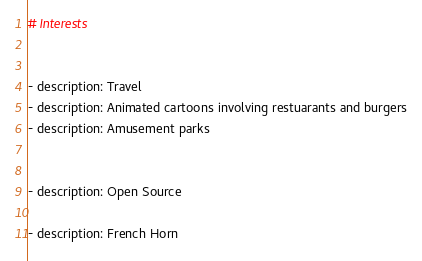Convert code to text. <code><loc_0><loc_0><loc_500><loc_500><_YAML_># Interests


- description: Travel
- description: Animated cartoons involving restuarants and burgers
- description: Amusement parks


- description: Open Source

- description: French Horn


</code> 